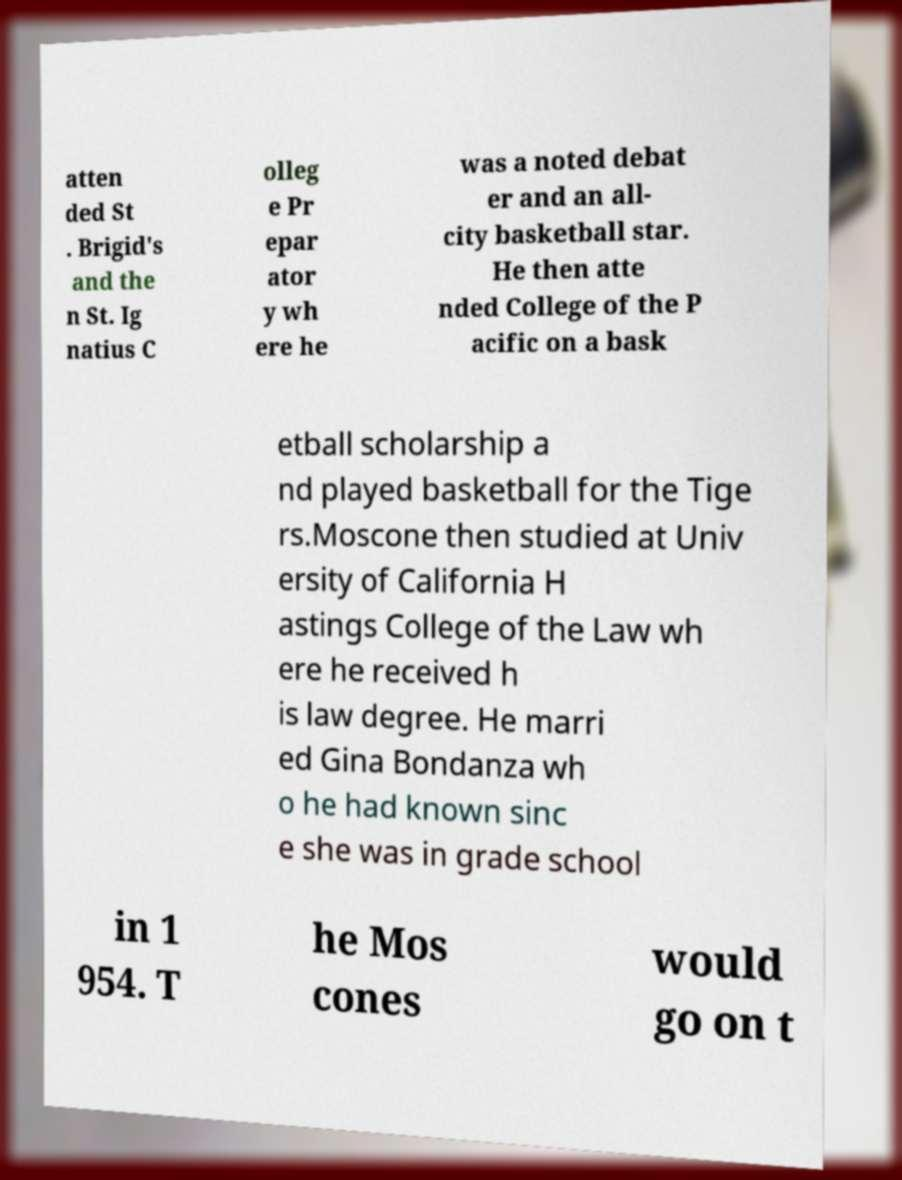There's text embedded in this image that I need extracted. Can you transcribe it verbatim? atten ded St . Brigid's and the n St. Ig natius C olleg e Pr epar ator y wh ere he was a noted debat er and an all- city basketball star. He then atte nded College of the P acific on a bask etball scholarship a nd played basketball for the Tige rs.Moscone then studied at Univ ersity of California H astings College of the Law wh ere he received h is law degree. He marri ed Gina Bondanza wh o he had known sinc e she was in grade school in 1 954. T he Mos cones would go on t 